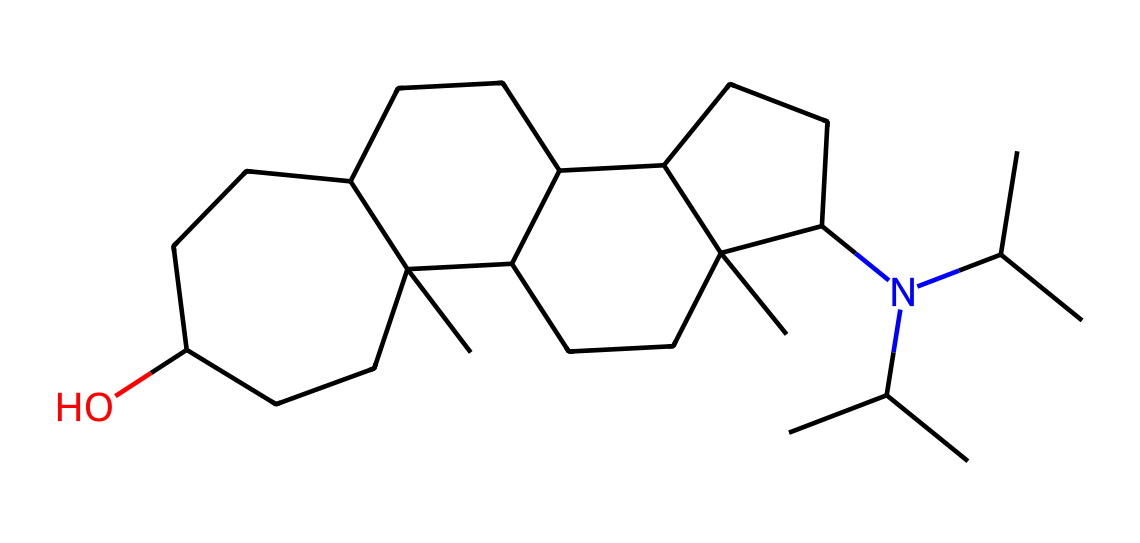What is the main functional group present in this compound? The chemical structure contains a hydroxyl group (-OH) indicated by the terminal 'O' bonded to a carbon chain, which is characteristic of alcohols.
Answer: hydroxyl group How many carbon atoms are in this compound? By analyzing the SMILES representation, we can count the number of 'C' atoms present; there are a total of 20 carbon atoms in the structure.
Answer: 20 What type of drug is represented by this chemical structure? This chemical structure corresponds to an opioid painkiller, as indicated by its complex cyclic structure and the presence of nitrogen, which is typical for opioids.
Answer: opioid What is the reason for the addictive potential of this compound? The addictive potential arises from its ability to bind to opioid receptors in the brain, leading to increased dopamine release, which reinforces rewarding effects.
Answer: opioid receptors Is there a stereocenter in this chemical compound? Upon examining the structure, there are chiral centers present due to the asymmetric carbon atoms in the cyclic rings, indicative of stereoisomers.
Answer: yes 